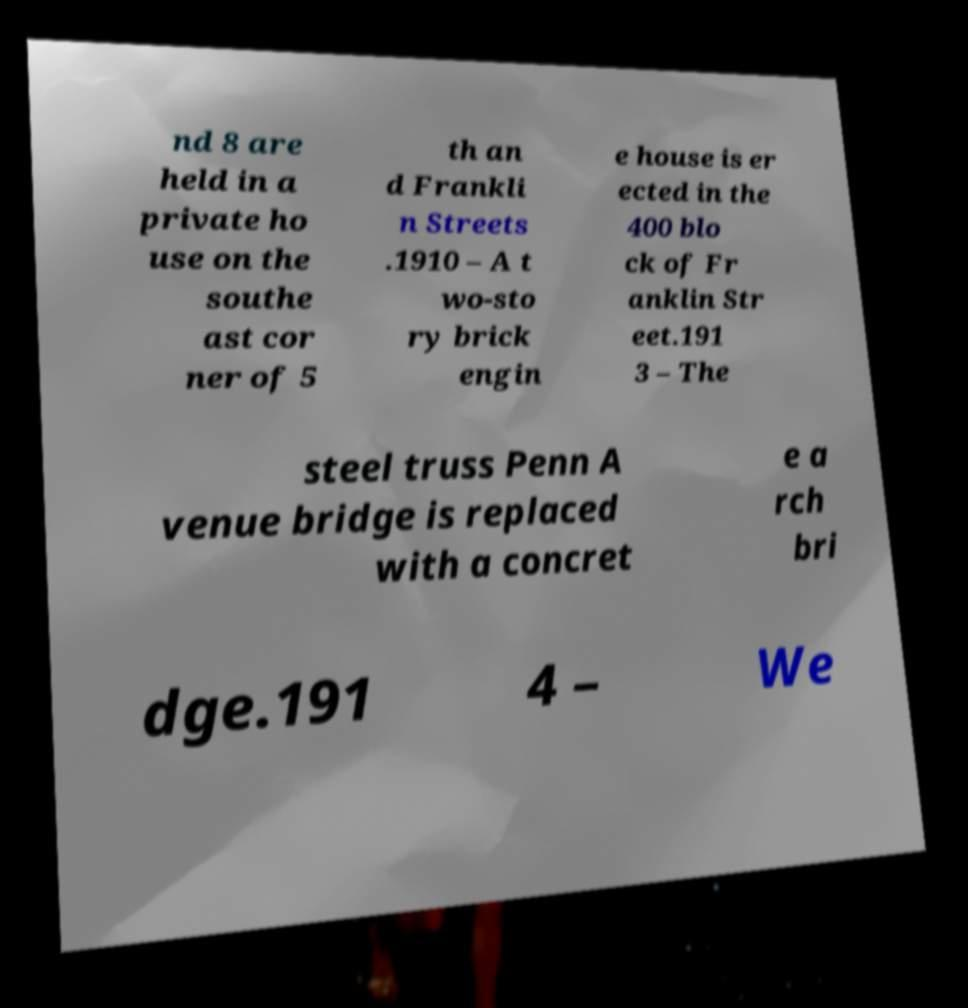Could you assist in decoding the text presented in this image and type it out clearly? nd 8 are held in a private ho use on the southe ast cor ner of 5 th an d Frankli n Streets .1910 – A t wo-sto ry brick engin e house is er ected in the 400 blo ck of Fr anklin Str eet.191 3 – The steel truss Penn A venue bridge is replaced with a concret e a rch bri dge.191 4 – We 